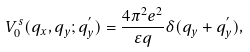<formula> <loc_0><loc_0><loc_500><loc_500>V ^ { s } _ { 0 } ( q _ { x } , q _ { y } ; q _ { y } ^ { ^ { \prime } } ) = \frac { 4 \pi ^ { 2 } e ^ { 2 } } { \varepsilon q } \delta ( q _ { y } + q _ { y } ^ { ^ { \prime } } ) ,</formula> 